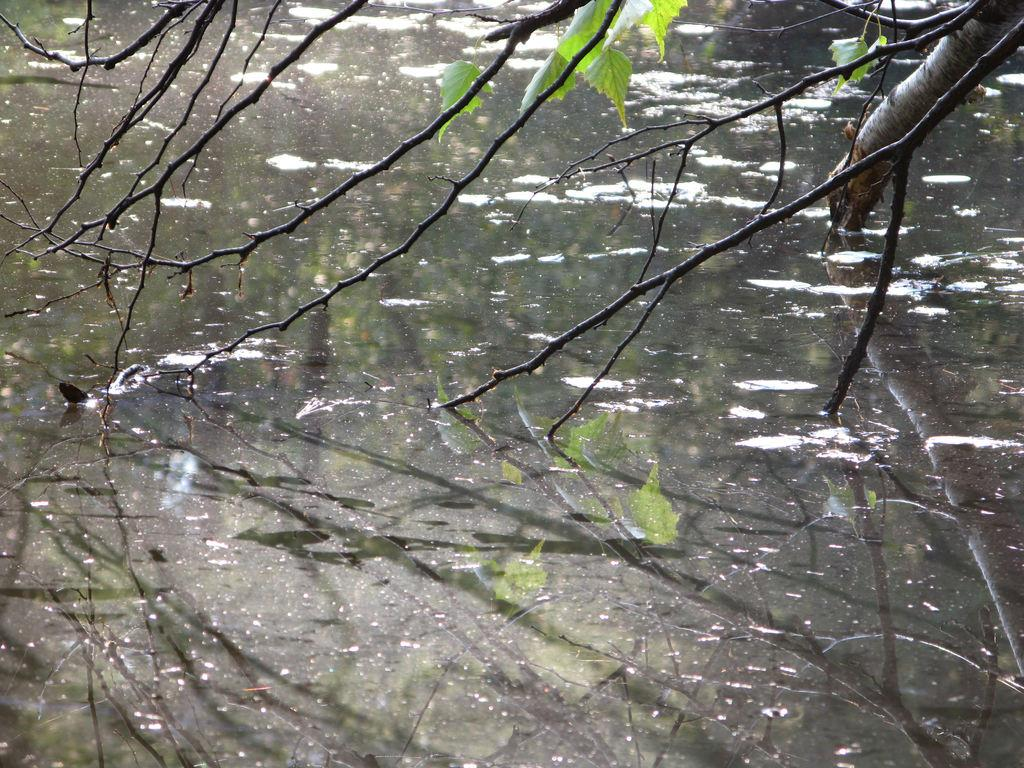What is the main feature of the image? The main feature of the image is a water surface. What can be seen above the water surface? There is a tree above the water surface. How would you describe the overall environment in the image? The area is mostly dry. What type of hair can be seen on the tree in the image? There is no hair present on the tree in the image; it is a tree with leaves or branches. 